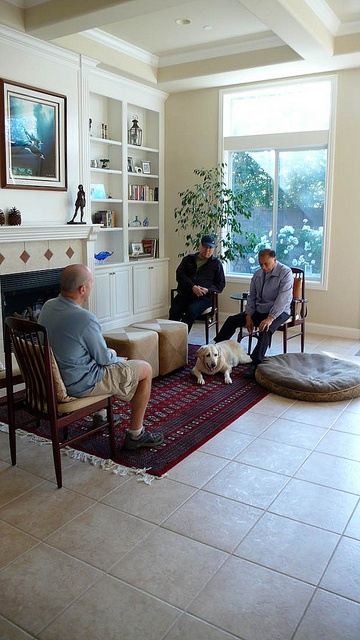Describe the objects in this image and their specific colors. I can see chair in gray, black, maroon, and darkgray tones, people in gray, black, blue, and darkgray tones, potted plant in gray, teal, and darkgray tones, people in gray and black tones, and people in gray, black, maroon, and darkgray tones in this image. 